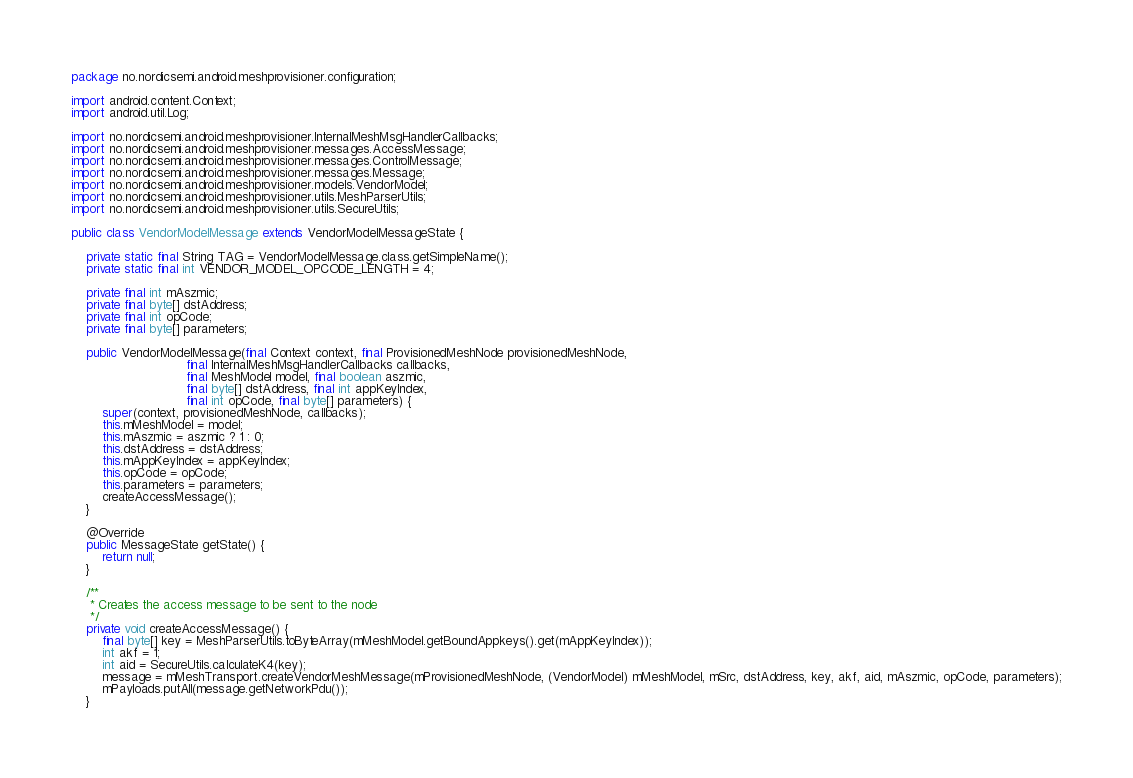Convert code to text. <code><loc_0><loc_0><loc_500><loc_500><_Java_>package no.nordicsemi.android.meshprovisioner.configuration;

import android.content.Context;
import android.util.Log;

import no.nordicsemi.android.meshprovisioner.InternalMeshMsgHandlerCallbacks;
import no.nordicsemi.android.meshprovisioner.messages.AccessMessage;
import no.nordicsemi.android.meshprovisioner.messages.ControlMessage;
import no.nordicsemi.android.meshprovisioner.messages.Message;
import no.nordicsemi.android.meshprovisioner.models.VendorModel;
import no.nordicsemi.android.meshprovisioner.utils.MeshParserUtils;
import no.nordicsemi.android.meshprovisioner.utils.SecureUtils;

public class VendorModelMessage extends VendorModelMessageState {

    private static final String TAG = VendorModelMessage.class.getSimpleName();
    private static final int VENDOR_MODEL_OPCODE_LENGTH = 4;

    private final int mAszmic;
    private final byte[] dstAddress;
    private final int opCode;
    private final byte[] parameters;

    public VendorModelMessage(final Context context, final ProvisionedMeshNode provisionedMeshNode,
                              final InternalMeshMsgHandlerCallbacks callbacks,
                              final MeshModel model, final boolean aszmic,
                              final byte[] dstAddress, final int appKeyIndex,
                              final int opCode, final byte[] parameters) {
        super(context, provisionedMeshNode, callbacks);
        this.mMeshModel = model;
        this.mAszmic = aszmic ? 1 : 0;
        this.dstAddress = dstAddress;
        this.mAppKeyIndex = appKeyIndex;
        this.opCode = opCode;
        this.parameters = parameters;
        createAccessMessage();
    }

    @Override
    public MessageState getState() {
        return null;
    }

    /**
     * Creates the access message to be sent to the node
     */
    private void createAccessMessage() {
        final byte[] key = MeshParserUtils.toByteArray(mMeshModel.getBoundAppkeys().get(mAppKeyIndex));
        int akf = 1;
        int aid = SecureUtils.calculateK4(key);
        message = mMeshTransport.createVendorMeshMessage(mProvisionedMeshNode, (VendorModel) mMeshModel, mSrc, dstAddress, key, akf, aid, mAszmic, opCode, parameters);
        mPayloads.putAll(message.getNetworkPdu());
    }
</code> 